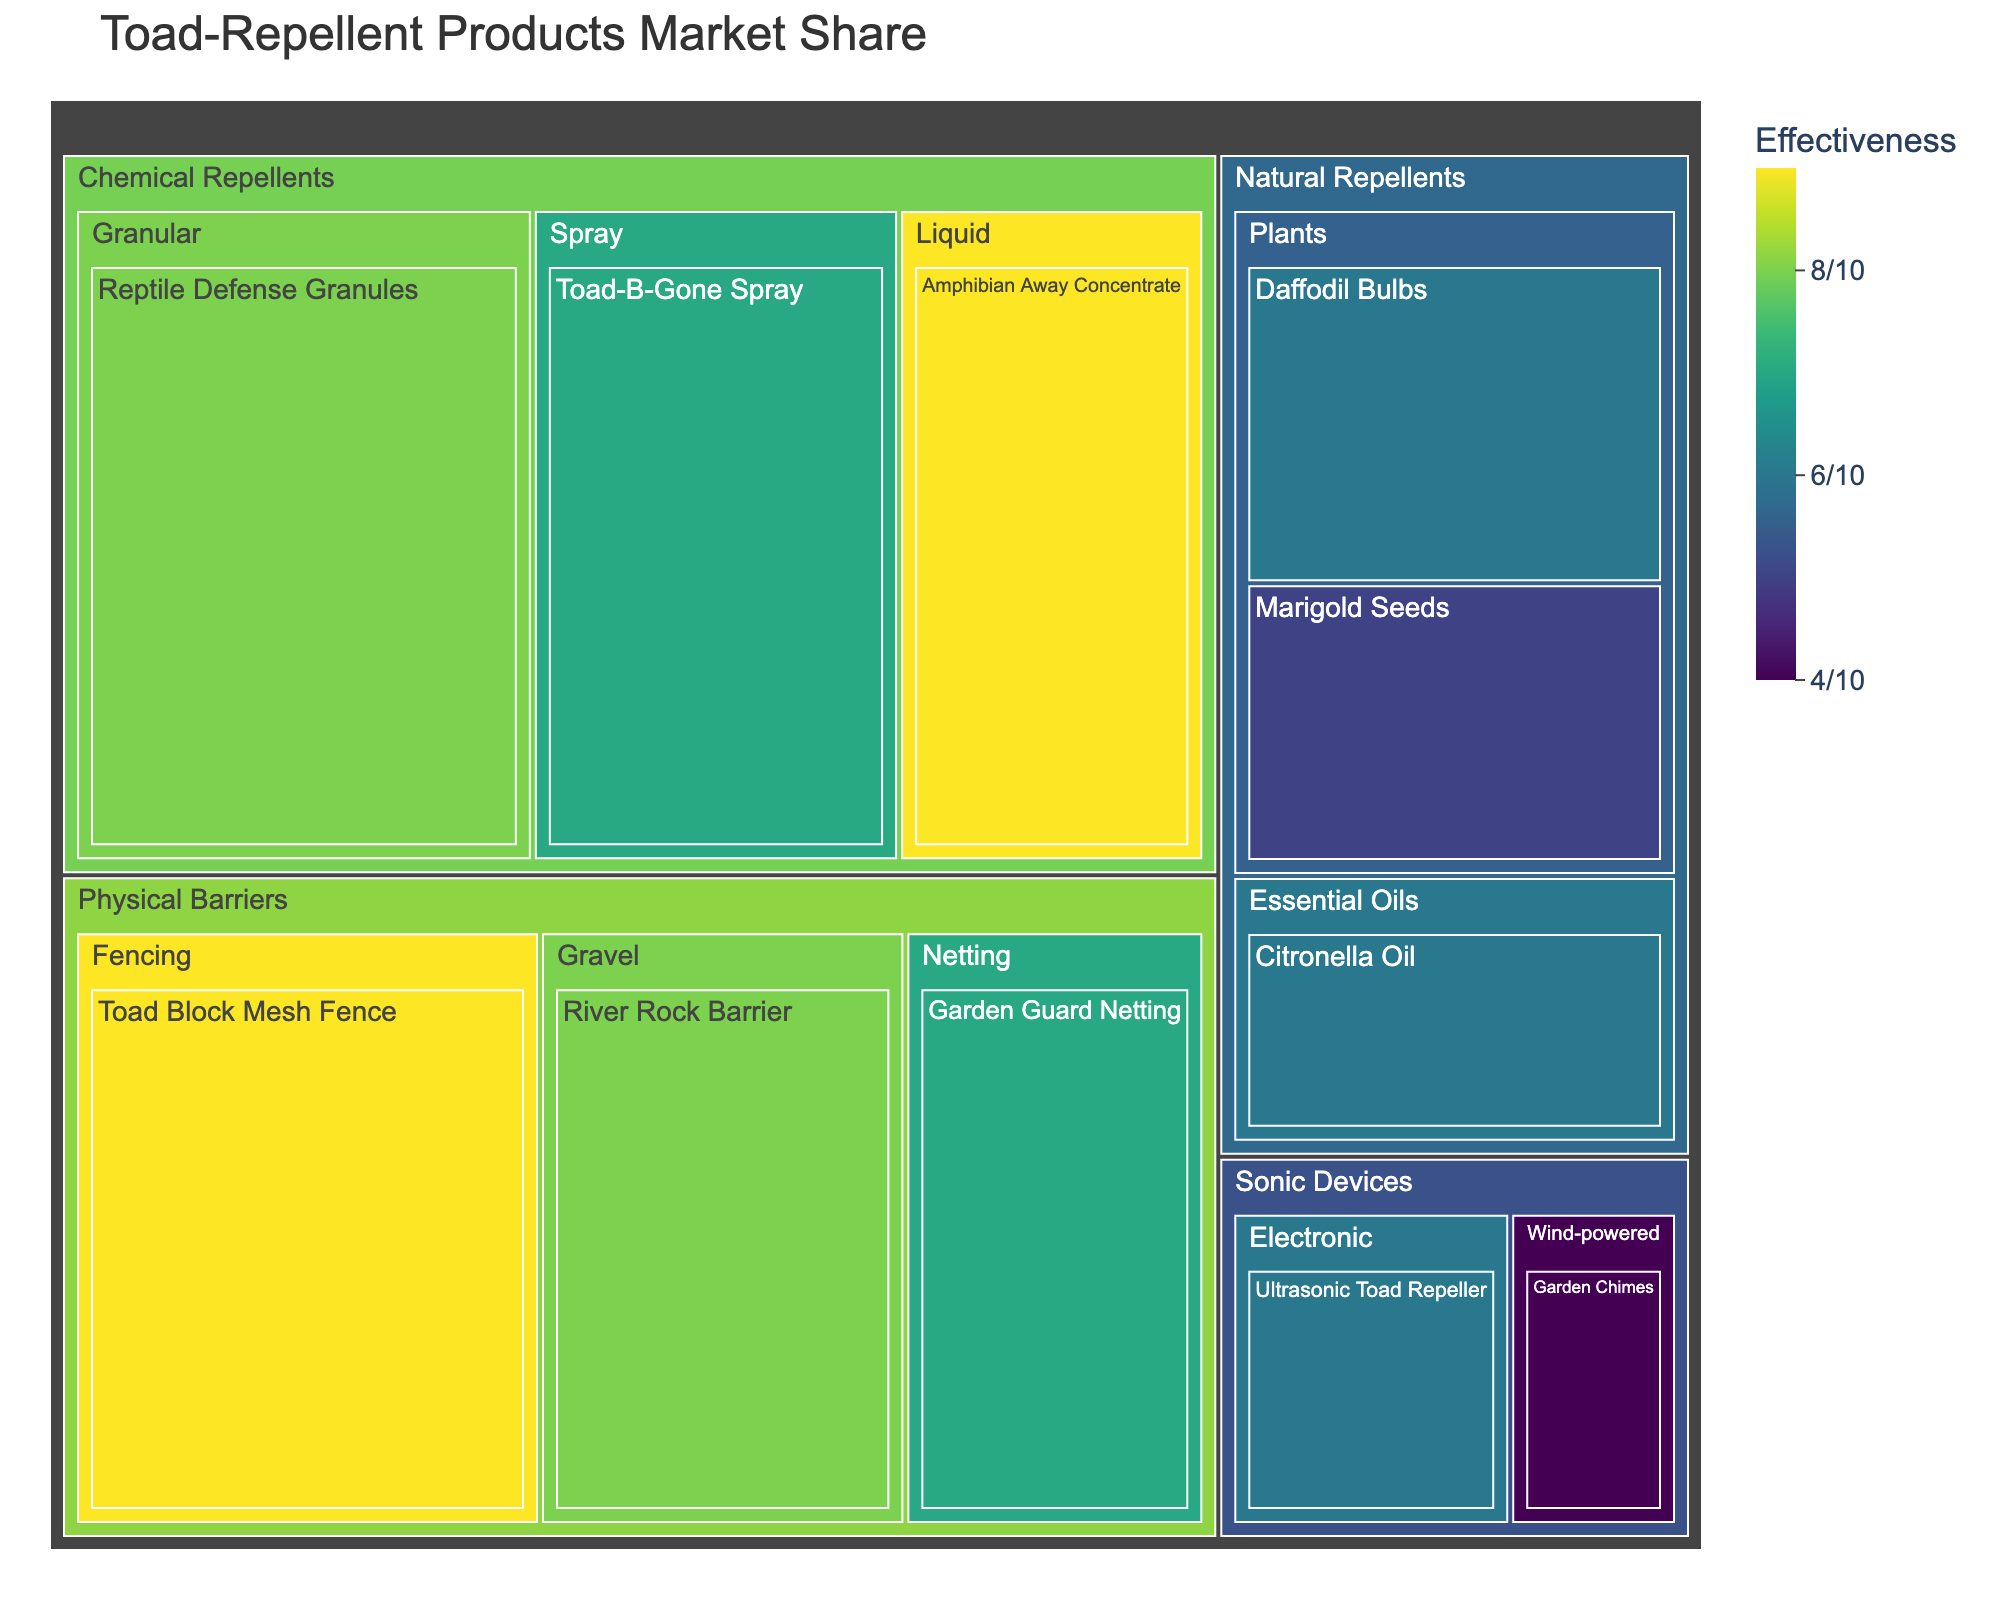What's the title of the treemap? The title of the treemap can be found at the top of the figure.
Answer: Toad-Repellent Products Market Share How many main categories are there and what are they? The main categories are identified by the first level of the treemap hierarchy.
Answer: Four: Chemical Repellents, Natural Repellents, Physical Barriers, Sonic Devices What subcategory and product has the highest market share in the Chemical Repellents category? Look within the Chemical Repellents section of the treemap and identify the subcategory and product with the largest box.
Answer: Subcategory: Granular, Product: Reptile Defense Granules What is the market share of Citronella Oil in the Natural Repellents category? Locate the Citronella Oil product within the Natural Repellents category and read the market share value.
Answer: 6% Which product has the highest effectiveness rating of 9 in the Physical Barriers category? Look within the Physical Barriers category and identify the product with an effectiveness rating of 9.
Answer: Toad Block Mesh Fence What is the total market share of the products in the Plants subcategory under Natural Repellents? Sum the market share values of the products in the Plants subcategory.
Answer: 15% How does the cost of the Ultrasonic Toad Repeller compare to the cost of Garden Guard Netting? Compare the cost values shown in the hover data for the two products.
Answer: Ultrasonic Toad Repeller: 8, Garden Guard Netting: 6. Ultrasonic Toad Repeller is more expensive Which subcategory within Physical Barriers has the lowest market share? Identify the subcategory within Physical Barriers that has the smallest box and check its market share.
Answer: Netting Between Marigold Seeds and Daffodil Bulbs, which product has a higher effectiveness in the Natural Repellents category? Compare the effectiveness ratings of Marigold Seeds and Daffodil Bulbs by hovering over their boxes.
Answer: Daffodil Bulbs with an effectiveness of 6 Excluding products from the Chemical Repellents category, which product has the highest cost? Identify and compare the cost of all products outside the Chemical Repellents category.
Answer: Toad Block Mesh Fence 